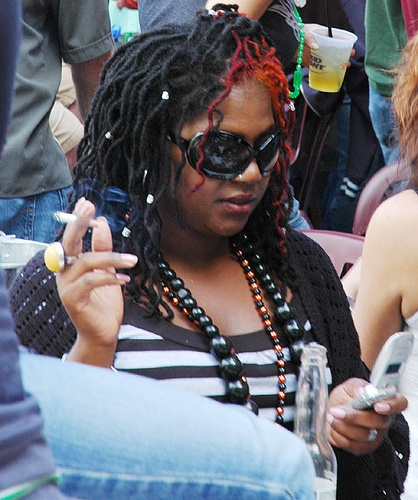Describe the objects in this image and their specific colors. I can see people in navy, black, gray, lightgray, and brown tones, people in navy, lightblue, and gray tones, people in navy, gray, and black tones, people in navy, lightgray, tan, and brown tones, and people in navy, black, gray, and blue tones in this image. 